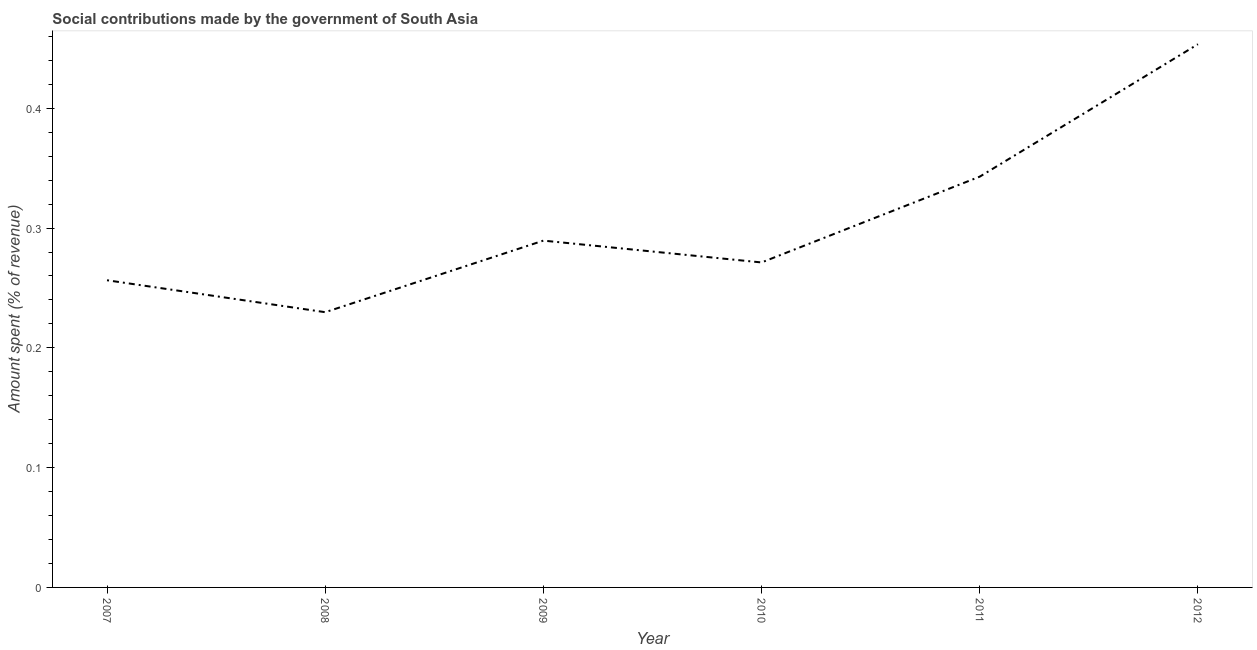What is the amount spent in making social contributions in 2008?
Keep it short and to the point. 0.23. Across all years, what is the maximum amount spent in making social contributions?
Provide a short and direct response. 0.45. Across all years, what is the minimum amount spent in making social contributions?
Offer a terse response. 0.23. In which year was the amount spent in making social contributions maximum?
Keep it short and to the point. 2012. What is the sum of the amount spent in making social contributions?
Make the answer very short. 1.84. What is the difference between the amount spent in making social contributions in 2010 and 2011?
Ensure brevity in your answer.  -0.07. What is the average amount spent in making social contributions per year?
Offer a terse response. 0.31. What is the median amount spent in making social contributions?
Provide a short and direct response. 0.28. What is the ratio of the amount spent in making social contributions in 2009 to that in 2010?
Ensure brevity in your answer.  1.07. Is the difference between the amount spent in making social contributions in 2009 and 2012 greater than the difference between any two years?
Keep it short and to the point. No. What is the difference between the highest and the second highest amount spent in making social contributions?
Keep it short and to the point. 0.11. Is the sum of the amount spent in making social contributions in 2007 and 2009 greater than the maximum amount spent in making social contributions across all years?
Keep it short and to the point. Yes. What is the difference between the highest and the lowest amount spent in making social contributions?
Provide a short and direct response. 0.22. In how many years, is the amount spent in making social contributions greater than the average amount spent in making social contributions taken over all years?
Your response must be concise. 2. How many years are there in the graph?
Keep it short and to the point. 6. What is the difference between two consecutive major ticks on the Y-axis?
Ensure brevity in your answer.  0.1. Does the graph contain any zero values?
Your response must be concise. No. What is the title of the graph?
Offer a very short reply. Social contributions made by the government of South Asia. What is the label or title of the X-axis?
Offer a terse response. Year. What is the label or title of the Y-axis?
Provide a succinct answer. Amount spent (% of revenue). What is the Amount spent (% of revenue) of 2007?
Keep it short and to the point. 0.26. What is the Amount spent (% of revenue) in 2008?
Provide a short and direct response. 0.23. What is the Amount spent (% of revenue) in 2009?
Your answer should be compact. 0.29. What is the Amount spent (% of revenue) in 2010?
Give a very brief answer. 0.27. What is the Amount spent (% of revenue) of 2011?
Provide a short and direct response. 0.34. What is the Amount spent (% of revenue) of 2012?
Provide a succinct answer. 0.45. What is the difference between the Amount spent (% of revenue) in 2007 and 2008?
Your answer should be compact. 0.03. What is the difference between the Amount spent (% of revenue) in 2007 and 2009?
Your answer should be very brief. -0.03. What is the difference between the Amount spent (% of revenue) in 2007 and 2010?
Offer a terse response. -0.01. What is the difference between the Amount spent (% of revenue) in 2007 and 2011?
Offer a terse response. -0.09. What is the difference between the Amount spent (% of revenue) in 2007 and 2012?
Offer a terse response. -0.2. What is the difference between the Amount spent (% of revenue) in 2008 and 2009?
Offer a very short reply. -0.06. What is the difference between the Amount spent (% of revenue) in 2008 and 2010?
Your answer should be compact. -0.04. What is the difference between the Amount spent (% of revenue) in 2008 and 2011?
Provide a succinct answer. -0.11. What is the difference between the Amount spent (% of revenue) in 2008 and 2012?
Your answer should be compact. -0.22. What is the difference between the Amount spent (% of revenue) in 2009 and 2010?
Give a very brief answer. 0.02. What is the difference between the Amount spent (% of revenue) in 2009 and 2011?
Make the answer very short. -0.05. What is the difference between the Amount spent (% of revenue) in 2009 and 2012?
Offer a terse response. -0.16. What is the difference between the Amount spent (% of revenue) in 2010 and 2011?
Make the answer very short. -0.07. What is the difference between the Amount spent (% of revenue) in 2010 and 2012?
Offer a very short reply. -0.18. What is the difference between the Amount spent (% of revenue) in 2011 and 2012?
Offer a terse response. -0.11. What is the ratio of the Amount spent (% of revenue) in 2007 to that in 2008?
Provide a short and direct response. 1.12. What is the ratio of the Amount spent (% of revenue) in 2007 to that in 2009?
Provide a short and direct response. 0.89. What is the ratio of the Amount spent (% of revenue) in 2007 to that in 2010?
Offer a terse response. 0.94. What is the ratio of the Amount spent (% of revenue) in 2007 to that in 2011?
Give a very brief answer. 0.75. What is the ratio of the Amount spent (% of revenue) in 2007 to that in 2012?
Offer a very short reply. 0.56. What is the ratio of the Amount spent (% of revenue) in 2008 to that in 2009?
Ensure brevity in your answer.  0.79. What is the ratio of the Amount spent (% of revenue) in 2008 to that in 2010?
Keep it short and to the point. 0.85. What is the ratio of the Amount spent (% of revenue) in 2008 to that in 2011?
Ensure brevity in your answer.  0.67. What is the ratio of the Amount spent (% of revenue) in 2008 to that in 2012?
Your answer should be compact. 0.51. What is the ratio of the Amount spent (% of revenue) in 2009 to that in 2010?
Give a very brief answer. 1.07. What is the ratio of the Amount spent (% of revenue) in 2009 to that in 2011?
Your answer should be very brief. 0.84. What is the ratio of the Amount spent (% of revenue) in 2009 to that in 2012?
Your answer should be compact. 0.64. What is the ratio of the Amount spent (% of revenue) in 2010 to that in 2011?
Provide a short and direct response. 0.79. What is the ratio of the Amount spent (% of revenue) in 2010 to that in 2012?
Give a very brief answer. 0.6. What is the ratio of the Amount spent (% of revenue) in 2011 to that in 2012?
Your answer should be compact. 0.76. 